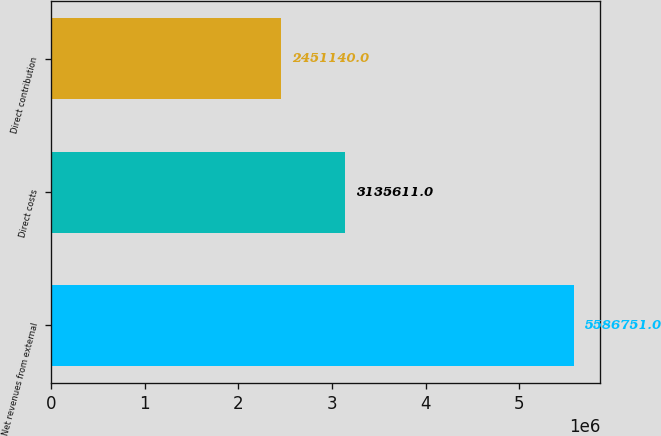Convert chart to OTSL. <chart><loc_0><loc_0><loc_500><loc_500><bar_chart><fcel>Net revenues from external<fcel>Direct costs<fcel>Direct contribution<nl><fcel>5.58675e+06<fcel>3.13561e+06<fcel>2.45114e+06<nl></chart> 